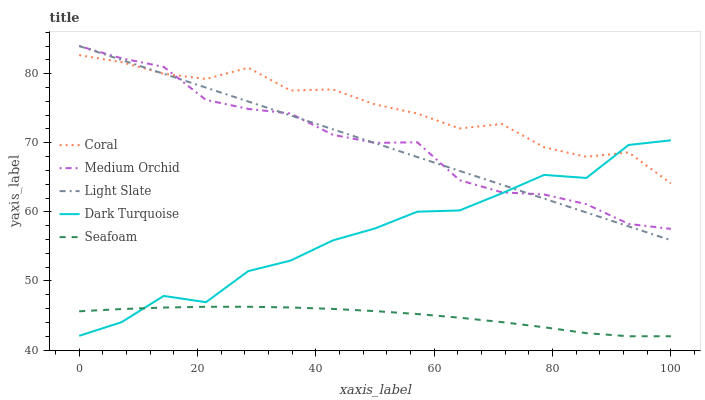Does Seafoam have the minimum area under the curve?
Answer yes or no. Yes. Does Coral have the maximum area under the curve?
Answer yes or no. Yes. Does Dark Turquoise have the minimum area under the curve?
Answer yes or no. No. Does Dark Turquoise have the maximum area under the curve?
Answer yes or no. No. Is Light Slate the smoothest?
Answer yes or no. Yes. Is Dark Turquoise the roughest?
Answer yes or no. Yes. Is Coral the smoothest?
Answer yes or no. No. Is Coral the roughest?
Answer yes or no. No. Does Seafoam have the lowest value?
Answer yes or no. Yes. Does Dark Turquoise have the lowest value?
Answer yes or no. No. Does Medium Orchid have the highest value?
Answer yes or no. Yes. Does Dark Turquoise have the highest value?
Answer yes or no. No. Is Seafoam less than Medium Orchid?
Answer yes or no. Yes. Is Coral greater than Seafoam?
Answer yes or no. Yes. Does Dark Turquoise intersect Medium Orchid?
Answer yes or no. Yes. Is Dark Turquoise less than Medium Orchid?
Answer yes or no. No. Is Dark Turquoise greater than Medium Orchid?
Answer yes or no. No. Does Seafoam intersect Medium Orchid?
Answer yes or no. No. 